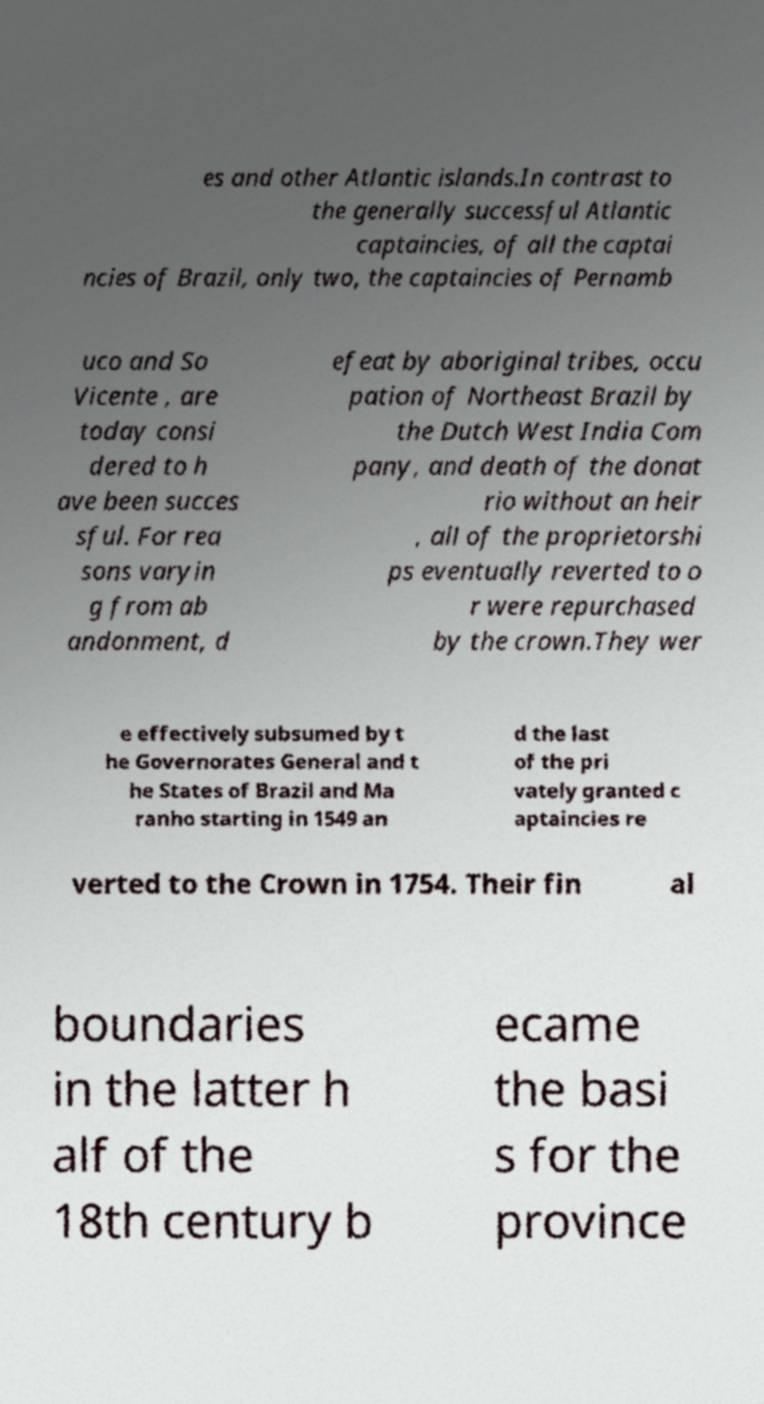For documentation purposes, I need the text within this image transcribed. Could you provide that? es and other Atlantic islands.In contrast to the generally successful Atlantic captaincies, of all the captai ncies of Brazil, only two, the captaincies of Pernamb uco and So Vicente , are today consi dered to h ave been succes sful. For rea sons varyin g from ab andonment, d efeat by aboriginal tribes, occu pation of Northeast Brazil by the Dutch West India Com pany, and death of the donat rio without an heir , all of the proprietorshi ps eventually reverted to o r were repurchased by the crown.They wer e effectively subsumed by t he Governorates General and t he States of Brazil and Ma ranho starting in 1549 an d the last of the pri vately granted c aptaincies re verted to the Crown in 1754. Their fin al boundaries in the latter h alf of the 18th century b ecame the basi s for the province 